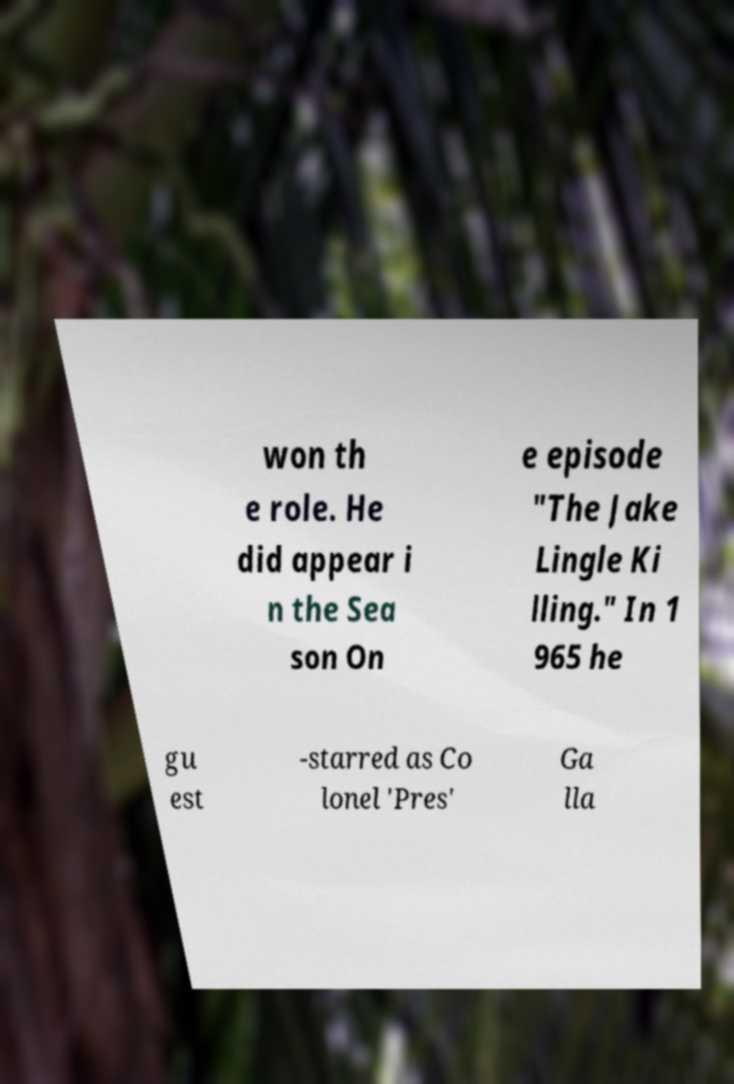Please read and relay the text visible in this image. What does it say? won th e role. He did appear i n the Sea son On e episode "The Jake Lingle Ki lling." In 1 965 he gu est -starred as Co lonel 'Pres' Ga lla 